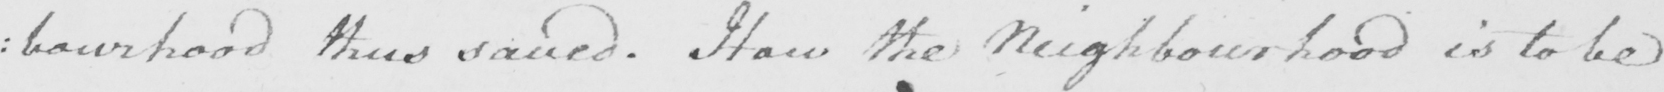What does this handwritten line say? : bourhood thus saved . How the Neighbourhood is to be 